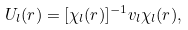Convert formula to latex. <formula><loc_0><loc_0><loc_500><loc_500>U _ { l } ( r ) = [ \chi _ { l } ( r ) ] ^ { - 1 } v _ { l } \chi _ { l } ( r ) ,</formula> 